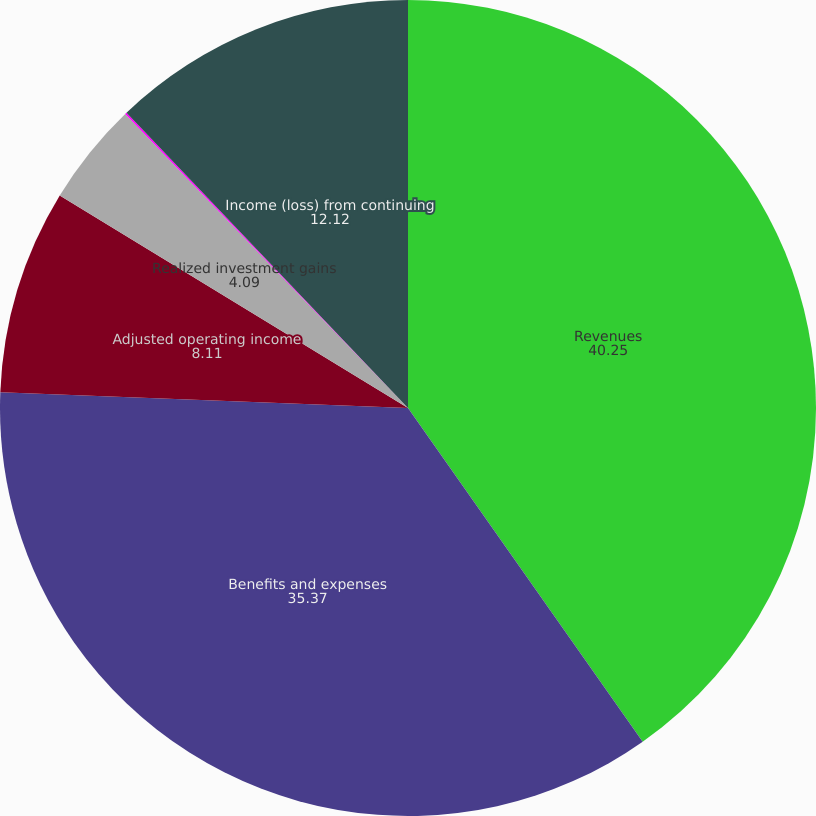Convert chart to OTSL. <chart><loc_0><loc_0><loc_500><loc_500><pie_chart><fcel>Revenues<fcel>Benefits and expenses<fcel>Adjusted operating income<fcel>Realized investment gains<fcel>Related charges<fcel>Income (loss) from continuing<nl><fcel>40.25%<fcel>35.37%<fcel>8.11%<fcel>4.09%<fcel>0.07%<fcel>12.12%<nl></chart> 